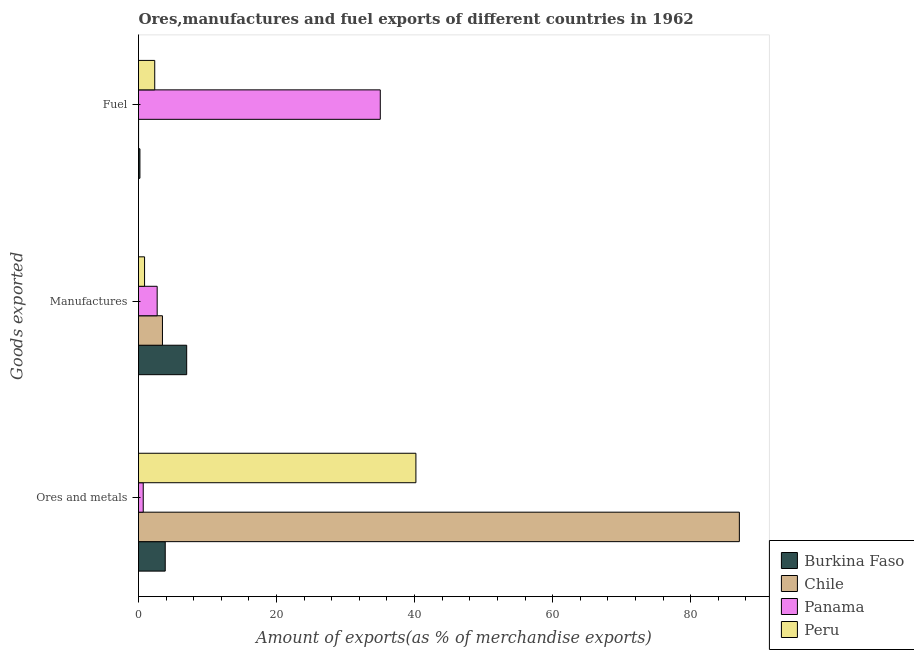How many different coloured bars are there?
Give a very brief answer. 4. How many groups of bars are there?
Keep it short and to the point. 3. How many bars are there on the 2nd tick from the bottom?
Make the answer very short. 4. What is the label of the 3rd group of bars from the top?
Provide a short and direct response. Ores and metals. What is the percentage of ores and metals exports in Chile?
Give a very brief answer. 87.06. Across all countries, what is the maximum percentage of ores and metals exports?
Your response must be concise. 87.06. Across all countries, what is the minimum percentage of manufactures exports?
Provide a succinct answer. 0.88. In which country was the percentage of manufactures exports maximum?
Give a very brief answer. Burkina Faso. In which country was the percentage of ores and metals exports minimum?
Ensure brevity in your answer.  Panama. What is the total percentage of fuel exports in the graph?
Your answer should be compact. 37.59. What is the difference between the percentage of manufactures exports in Burkina Faso and that in Peru?
Keep it short and to the point. 6.11. What is the difference between the percentage of manufactures exports in Chile and the percentage of fuel exports in Peru?
Give a very brief answer. 1.12. What is the average percentage of manufactures exports per country?
Ensure brevity in your answer.  3.51. What is the difference between the percentage of ores and metals exports and percentage of fuel exports in Panama?
Your answer should be very brief. -34.34. What is the ratio of the percentage of ores and metals exports in Chile to that in Panama?
Offer a terse response. 127.06. Is the percentage of manufactures exports in Peru less than that in Burkina Faso?
Your response must be concise. Yes. What is the difference between the highest and the second highest percentage of fuel exports?
Offer a very short reply. 32.68. What is the difference between the highest and the lowest percentage of fuel exports?
Keep it short and to the point. 35.02. In how many countries, is the percentage of ores and metals exports greater than the average percentage of ores and metals exports taken over all countries?
Offer a very short reply. 2. Is the sum of the percentage of ores and metals exports in Peru and Panama greater than the maximum percentage of fuel exports across all countries?
Provide a succinct answer. Yes. What does the 1st bar from the bottom in Manufactures represents?
Give a very brief answer. Burkina Faso. Is it the case that in every country, the sum of the percentage of ores and metals exports and percentage of manufactures exports is greater than the percentage of fuel exports?
Provide a short and direct response. No. How many bars are there?
Your answer should be compact. 12. Are all the bars in the graph horizontal?
Provide a short and direct response. Yes. How many countries are there in the graph?
Keep it short and to the point. 4. Does the graph contain any zero values?
Offer a very short reply. No. Does the graph contain grids?
Your response must be concise. No. How many legend labels are there?
Ensure brevity in your answer.  4. What is the title of the graph?
Your answer should be very brief. Ores,manufactures and fuel exports of different countries in 1962. What is the label or title of the X-axis?
Make the answer very short. Amount of exports(as % of merchandise exports). What is the label or title of the Y-axis?
Make the answer very short. Goods exported. What is the Amount of exports(as % of merchandise exports) in Burkina Faso in Ores and metals?
Your answer should be compact. 3.87. What is the Amount of exports(as % of merchandise exports) in Chile in Ores and metals?
Ensure brevity in your answer.  87.06. What is the Amount of exports(as % of merchandise exports) of Panama in Ores and metals?
Offer a terse response. 0.69. What is the Amount of exports(as % of merchandise exports) in Peru in Ores and metals?
Provide a succinct answer. 40.19. What is the Amount of exports(as % of merchandise exports) in Burkina Faso in Manufactures?
Provide a short and direct response. 6.98. What is the Amount of exports(as % of merchandise exports) of Chile in Manufactures?
Provide a short and direct response. 3.47. What is the Amount of exports(as % of merchandise exports) of Panama in Manufactures?
Offer a very short reply. 2.7. What is the Amount of exports(as % of merchandise exports) in Peru in Manufactures?
Provide a short and direct response. 0.88. What is the Amount of exports(as % of merchandise exports) in Burkina Faso in Fuel?
Offer a very short reply. 0.21. What is the Amount of exports(as % of merchandise exports) in Chile in Fuel?
Your answer should be compact. 0.01. What is the Amount of exports(as % of merchandise exports) of Panama in Fuel?
Your response must be concise. 35.03. What is the Amount of exports(as % of merchandise exports) in Peru in Fuel?
Provide a succinct answer. 2.35. Across all Goods exported, what is the maximum Amount of exports(as % of merchandise exports) of Burkina Faso?
Offer a very short reply. 6.98. Across all Goods exported, what is the maximum Amount of exports(as % of merchandise exports) in Chile?
Your answer should be compact. 87.06. Across all Goods exported, what is the maximum Amount of exports(as % of merchandise exports) in Panama?
Offer a terse response. 35.03. Across all Goods exported, what is the maximum Amount of exports(as % of merchandise exports) in Peru?
Your answer should be compact. 40.19. Across all Goods exported, what is the minimum Amount of exports(as % of merchandise exports) in Burkina Faso?
Offer a very short reply. 0.21. Across all Goods exported, what is the minimum Amount of exports(as % of merchandise exports) in Chile?
Keep it short and to the point. 0.01. Across all Goods exported, what is the minimum Amount of exports(as % of merchandise exports) in Panama?
Offer a very short reply. 0.69. Across all Goods exported, what is the minimum Amount of exports(as % of merchandise exports) of Peru?
Provide a short and direct response. 0.88. What is the total Amount of exports(as % of merchandise exports) in Burkina Faso in the graph?
Provide a short and direct response. 11.06. What is the total Amount of exports(as % of merchandise exports) of Chile in the graph?
Your answer should be compact. 90.53. What is the total Amount of exports(as % of merchandise exports) of Panama in the graph?
Your answer should be very brief. 38.42. What is the total Amount of exports(as % of merchandise exports) in Peru in the graph?
Ensure brevity in your answer.  43.42. What is the difference between the Amount of exports(as % of merchandise exports) of Burkina Faso in Ores and metals and that in Manufactures?
Your response must be concise. -3.11. What is the difference between the Amount of exports(as % of merchandise exports) of Chile in Ores and metals and that in Manufactures?
Give a very brief answer. 83.59. What is the difference between the Amount of exports(as % of merchandise exports) in Panama in Ores and metals and that in Manufactures?
Your response must be concise. -2.02. What is the difference between the Amount of exports(as % of merchandise exports) of Peru in Ores and metals and that in Manufactures?
Your answer should be very brief. 39.32. What is the difference between the Amount of exports(as % of merchandise exports) in Burkina Faso in Ores and metals and that in Fuel?
Ensure brevity in your answer.  3.67. What is the difference between the Amount of exports(as % of merchandise exports) in Chile in Ores and metals and that in Fuel?
Give a very brief answer. 87.05. What is the difference between the Amount of exports(as % of merchandise exports) in Panama in Ores and metals and that in Fuel?
Give a very brief answer. -34.34. What is the difference between the Amount of exports(as % of merchandise exports) of Peru in Ores and metals and that in Fuel?
Your answer should be very brief. 37.84. What is the difference between the Amount of exports(as % of merchandise exports) of Burkina Faso in Manufactures and that in Fuel?
Your answer should be very brief. 6.78. What is the difference between the Amount of exports(as % of merchandise exports) of Chile in Manufactures and that in Fuel?
Give a very brief answer. 3.46. What is the difference between the Amount of exports(as % of merchandise exports) of Panama in Manufactures and that in Fuel?
Your answer should be compact. -32.33. What is the difference between the Amount of exports(as % of merchandise exports) of Peru in Manufactures and that in Fuel?
Give a very brief answer. -1.47. What is the difference between the Amount of exports(as % of merchandise exports) of Burkina Faso in Ores and metals and the Amount of exports(as % of merchandise exports) of Chile in Manufactures?
Ensure brevity in your answer.  0.4. What is the difference between the Amount of exports(as % of merchandise exports) of Burkina Faso in Ores and metals and the Amount of exports(as % of merchandise exports) of Panama in Manufactures?
Offer a very short reply. 1.17. What is the difference between the Amount of exports(as % of merchandise exports) in Burkina Faso in Ores and metals and the Amount of exports(as % of merchandise exports) in Peru in Manufactures?
Your answer should be very brief. 3. What is the difference between the Amount of exports(as % of merchandise exports) of Chile in Ores and metals and the Amount of exports(as % of merchandise exports) of Panama in Manufactures?
Your answer should be very brief. 84.35. What is the difference between the Amount of exports(as % of merchandise exports) in Chile in Ores and metals and the Amount of exports(as % of merchandise exports) in Peru in Manufactures?
Ensure brevity in your answer.  86.18. What is the difference between the Amount of exports(as % of merchandise exports) of Panama in Ores and metals and the Amount of exports(as % of merchandise exports) of Peru in Manufactures?
Make the answer very short. -0.19. What is the difference between the Amount of exports(as % of merchandise exports) of Burkina Faso in Ores and metals and the Amount of exports(as % of merchandise exports) of Chile in Fuel?
Offer a terse response. 3.87. What is the difference between the Amount of exports(as % of merchandise exports) in Burkina Faso in Ores and metals and the Amount of exports(as % of merchandise exports) in Panama in Fuel?
Offer a terse response. -31.16. What is the difference between the Amount of exports(as % of merchandise exports) of Burkina Faso in Ores and metals and the Amount of exports(as % of merchandise exports) of Peru in Fuel?
Offer a very short reply. 1.52. What is the difference between the Amount of exports(as % of merchandise exports) of Chile in Ores and metals and the Amount of exports(as % of merchandise exports) of Panama in Fuel?
Offer a very short reply. 52.03. What is the difference between the Amount of exports(as % of merchandise exports) of Chile in Ores and metals and the Amount of exports(as % of merchandise exports) of Peru in Fuel?
Offer a terse response. 84.71. What is the difference between the Amount of exports(as % of merchandise exports) in Panama in Ores and metals and the Amount of exports(as % of merchandise exports) in Peru in Fuel?
Make the answer very short. -1.66. What is the difference between the Amount of exports(as % of merchandise exports) in Burkina Faso in Manufactures and the Amount of exports(as % of merchandise exports) in Chile in Fuel?
Your answer should be very brief. 6.97. What is the difference between the Amount of exports(as % of merchandise exports) in Burkina Faso in Manufactures and the Amount of exports(as % of merchandise exports) in Panama in Fuel?
Your response must be concise. -28.05. What is the difference between the Amount of exports(as % of merchandise exports) in Burkina Faso in Manufactures and the Amount of exports(as % of merchandise exports) in Peru in Fuel?
Provide a short and direct response. 4.63. What is the difference between the Amount of exports(as % of merchandise exports) in Chile in Manufactures and the Amount of exports(as % of merchandise exports) in Panama in Fuel?
Make the answer very short. -31.56. What is the difference between the Amount of exports(as % of merchandise exports) in Chile in Manufactures and the Amount of exports(as % of merchandise exports) in Peru in Fuel?
Your answer should be compact. 1.12. What is the difference between the Amount of exports(as % of merchandise exports) of Panama in Manufactures and the Amount of exports(as % of merchandise exports) of Peru in Fuel?
Ensure brevity in your answer.  0.35. What is the average Amount of exports(as % of merchandise exports) of Burkina Faso per Goods exported?
Offer a very short reply. 3.69. What is the average Amount of exports(as % of merchandise exports) of Chile per Goods exported?
Offer a very short reply. 30.18. What is the average Amount of exports(as % of merchandise exports) in Panama per Goods exported?
Your response must be concise. 12.81. What is the average Amount of exports(as % of merchandise exports) of Peru per Goods exported?
Ensure brevity in your answer.  14.47. What is the difference between the Amount of exports(as % of merchandise exports) of Burkina Faso and Amount of exports(as % of merchandise exports) of Chile in Ores and metals?
Offer a very short reply. -83.18. What is the difference between the Amount of exports(as % of merchandise exports) in Burkina Faso and Amount of exports(as % of merchandise exports) in Panama in Ores and metals?
Make the answer very short. 3.19. What is the difference between the Amount of exports(as % of merchandise exports) in Burkina Faso and Amount of exports(as % of merchandise exports) in Peru in Ores and metals?
Ensure brevity in your answer.  -36.32. What is the difference between the Amount of exports(as % of merchandise exports) in Chile and Amount of exports(as % of merchandise exports) in Panama in Ores and metals?
Offer a very short reply. 86.37. What is the difference between the Amount of exports(as % of merchandise exports) of Chile and Amount of exports(as % of merchandise exports) of Peru in Ores and metals?
Make the answer very short. 46.86. What is the difference between the Amount of exports(as % of merchandise exports) in Panama and Amount of exports(as % of merchandise exports) in Peru in Ores and metals?
Provide a short and direct response. -39.51. What is the difference between the Amount of exports(as % of merchandise exports) of Burkina Faso and Amount of exports(as % of merchandise exports) of Chile in Manufactures?
Make the answer very short. 3.51. What is the difference between the Amount of exports(as % of merchandise exports) of Burkina Faso and Amount of exports(as % of merchandise exports) of Panama in Manufactures?
Give a very brief answer. 4.28. What is the difference between the Amount of exports(as % of merchandise exports) of Burkina Faso and Amount of exports(as % of merchandise exports) of Peru in Manufactures?
Give a very brief answer. 6.11. What is the difference between the Amount of exports(as % of merchandise exports) in Chile and Amount of exports(as % of merchandise exports) in Panama in Manufactures?
Ensure brevity in your answer.  0.77. What is the difference between the Amount of exports(as % of merchandise exports) of Chile and Amount of exports(as % of merchandise exports) of Peru in Manufactures?
Offer a terse response. 2.59. What is the difference between the Amount of exports(as % of merchandise exports) of Panama and Amount of exports(as % of merchandise exports) of Peru in Manufactures?
Provide a short and direct response. 1.83. What is the difference between the Amount of exports(as % of merchandise exports) in Burkina Faso and Amount of exports(as % of merchandise exports) in Chile in Fuel?
Provide a succinct answer. 0.2. What is the difference between the Amount of exports(as % of merchandise exports) in Burkina Faso and Amount of exports(as % of merchandise exports) in Panama in Fuel?
Provide a short and direct response. -34.82. What is the difference between the Amount of exports(as % of merchandise exports) of Burkina Faso and Amount of exports(as % of merchandise exports) of Peru in Fuel?
Make the answer very short. -2.14. What is the difference between the Amount of exports(as % of merchandise exports) in Chile and Amount of exports(as % of merchandise exports) in Panama in Fuel?
Your response must be concise. -35.02. What is the difference between the Amount of exports(as % of merchandise exports) of Chile and Amount of exports(as % of merchandise exports) of Peru in Fuel?
Offer a terse response. -2.34. What is the difference between the Amount of exports(as % of merchandise exports) in Panama and Amount of exports(as % of merchandise exports) in Peru in Fuel?
Provide a short and direct response. 32.68. What is the ratio of the Amount of exports(as % of merchandise exports) in Burkina Faso in Ores and metals to that in Manufactures?
Make the answer very short. 0.55. What is the ratio of the Amount of exports(as % of merchandise exports) in Chile in Ores and metals to that in Manufactures?
Your response must be concise. 25.1. What is the ratio of the Amount of exports(as % of merchandise exports) of Panama in Ores and metals to that in Manufactures?
Your answer should be very brief. 0.25. What is the ratio of the Amount of exports(as % of merchandise exports) in Peru in Ores and metals to that in Manufactures?
Offer a terse response. 45.87. What is the ratio of the Amount of exports(as % of merchandise exports) in Burkina Faso in Ores and metals to that in Fuel?
Give a very brief answer. 18.88. What is the ratio of the Amount of exports(as % of merchandise exports) of Chile in Ores and metals to that in Fuel?
Provide a short and direct response. 1.24e+04. What is the ratio of the Amount of exports(as % of merchandise exports) in Panama in Ores and metals to that in Fuel?
Your response must be concise. 0.02. What is the ratio of the Amount of exports(as % of merchandise exports) in Peru in Ores and metals to that in Fuel?
Keep it short and to the point. 17.1. What is the ratio of the Amount of exports(as % of merchandise exports) in Burkina Faso in Manufactures to that in Fuel?
Your answer should be compact. 34.05. What is the ratio of the Amount of exports(as % of merchandise exports) in Chile in Manufactures to that in Fuel?
Your answer should be very brief. 495.17. What is the ratio of the Amount of exports(as % of merchandise exports) in Panama in Manufactures to that in Fuel?
Your answer should be compact. 0.08. What is the ratio of the Amount of exports(as % of merchandise exports) of Peru in Manufactures to that in Fuel?
Your answer should be compact. 0.37. What is the difference between the highest and the second highest Amount of exports(as % of merchandise exports) of Burkina Faso?
Keep it short and to the point. 3.11. What is the difference between the highest and the second highest Amount of exports(as % of merchandise exports) in Chile?
Keep it short and to the point. 83.59. What is the difference between the highest and the second highest Amount of exports(as % of merchandise exports) of Panama?
Keep it short and to the point. 32.33. What is the difference between the highest and the second highest Amount of exports(as % of merchandise exports) in Peru?
Offer a very short reply. 37.84. What is the difference between the highest and the lowest Amount of exports(as % of merchandise exports) of Burkina Faso?
Keep it short and to the point. 6.78. What is the difference between the highest and the lowest Amount of exports(as % of merchandise exports) in Chile?
Ensure brevity in your answer.  87.05. What is the difference between the highest and the lowest Amount of exports(as % of merchandise exports) in Panama?
Offer a terse response. 34.34. What is the difference between the highest and the lowest Amount of exports(as % of merchandise exports) in Peru?
Make the answer very short. 39.32. 